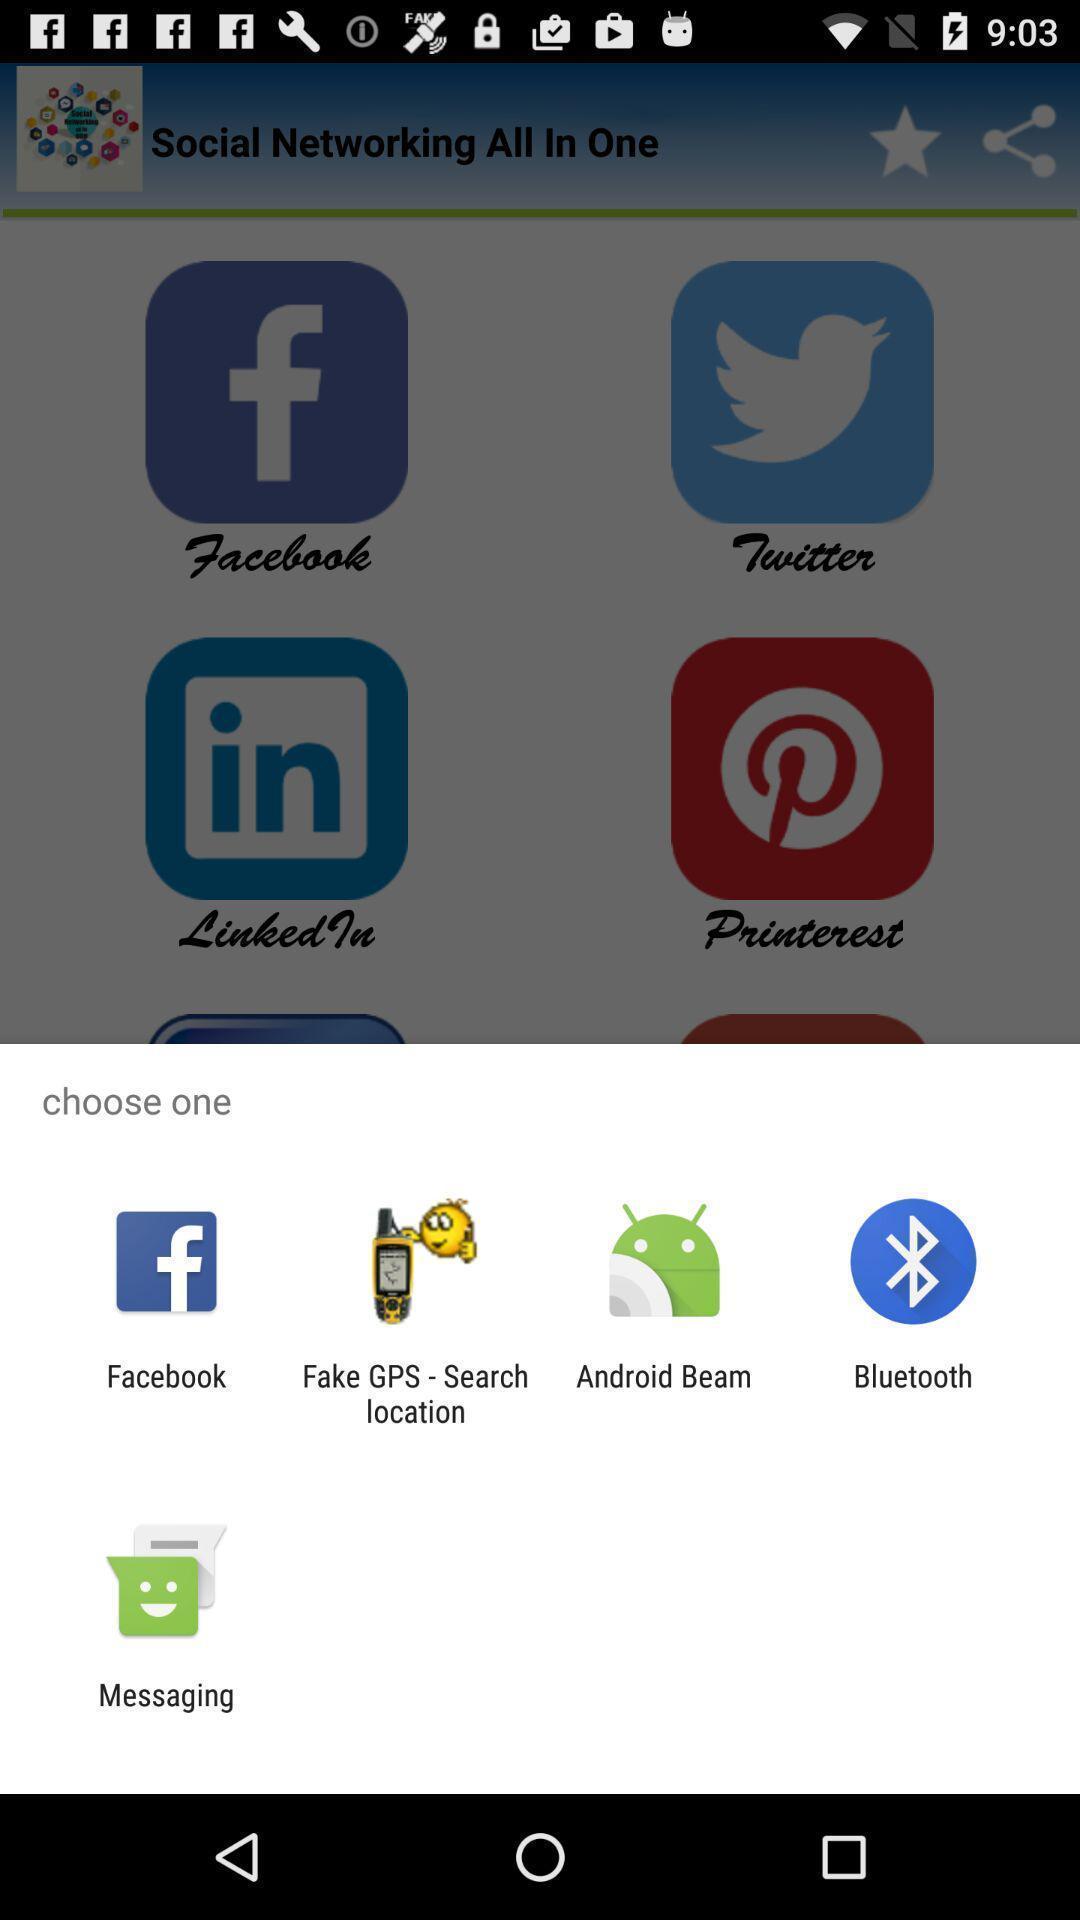What can you discern from this picture? Pop up showing various apps. 